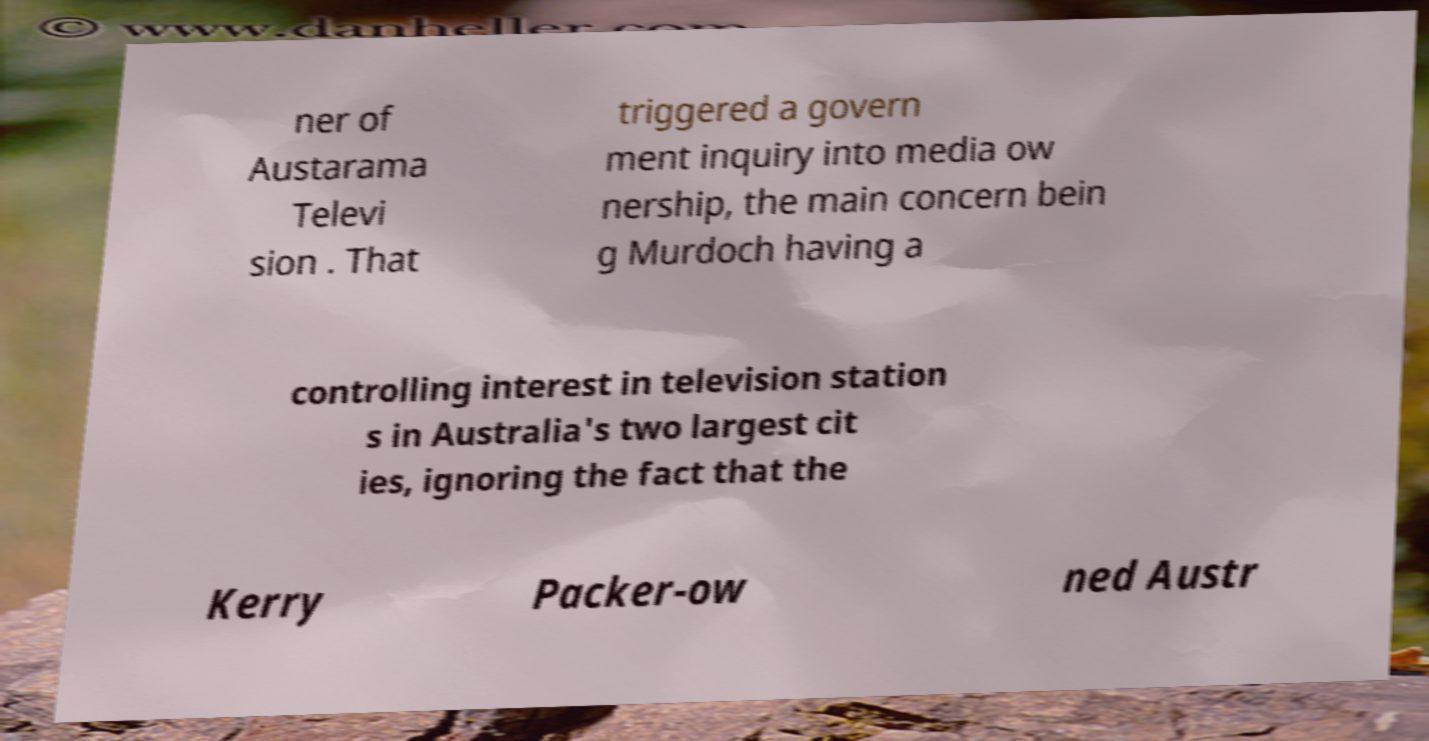Can you accurately transcribe the text from the provided image for me? ner of Austarama Televi sion . That triggered a govern ment inquiry into media ow nership, the main concern bein g Murdoch having a controlling interest in television station s in Australia's two largest cit ies, ignoring the fact that the Kerry Packer-ow ned Austr 